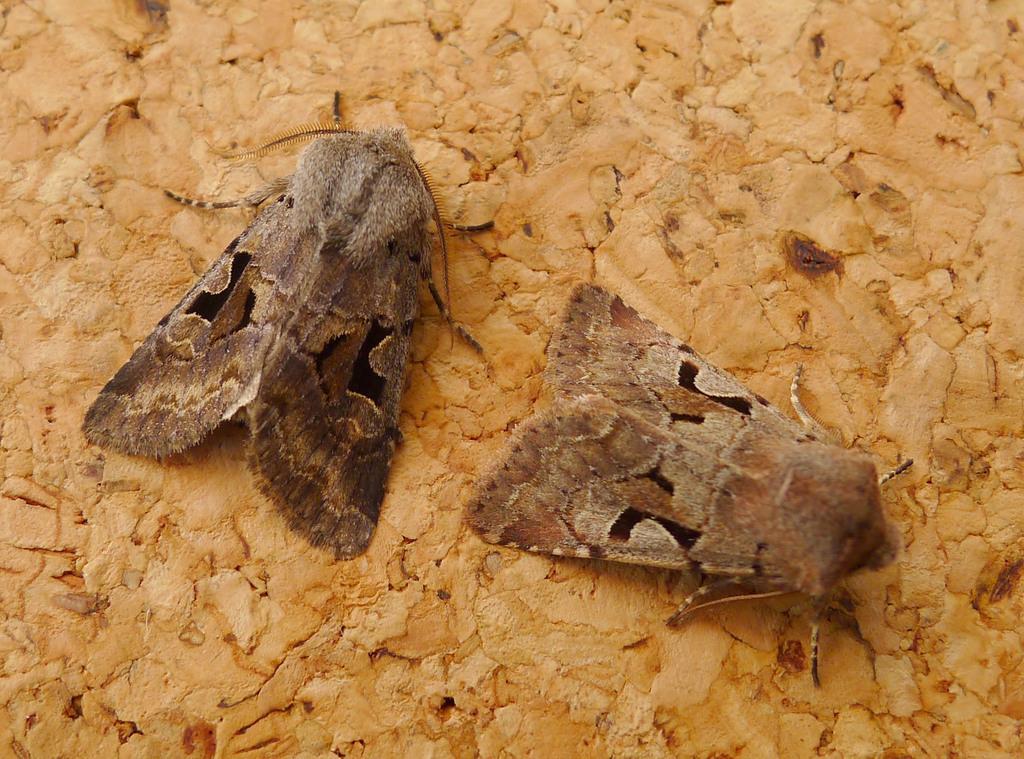Can you describe this image briefly? In this image we can see few insects. The background looks like a wooden surface. 